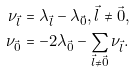Convert formula to latex. <formula><loc_0><loc_0><loc_500><loc_500>\nu _ { \vec { l } } & = \lambda _ { \vec { l } } - \lambda _ { \vec { 0 } } , \vec { l } \neq \vec { 0 } , \\ \nu _ { \vec { 0 } } & = - 2 \lambda _ { \vec { 0 } } - \sum _ { \vec { l } \neq \vec { 0 } } \nu _ { \vec { l } } .</formula> 